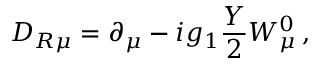<formula> <loc_0><loc_0><loc_500><loc_500>D _ { R \mu } = \partial _ { \mu } - i g _ { 1 } \frac { Y } { 2 } W _ { \mu } ^ { 0 } \, ,</formula> 